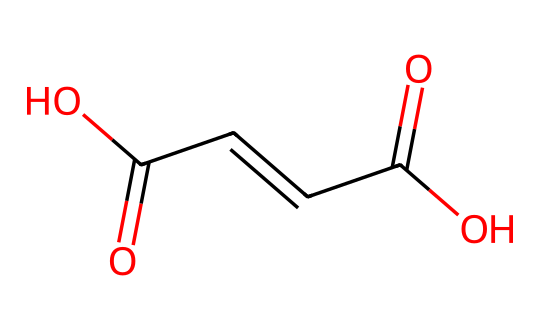What is the IUPAC name of this compound? The structure shown is a dicarboxylic acid, which features two carboxylic acid (-COOH) groups, and its systematic name follows the conventions for naming such compounds. The correct naming convention leads to the name "fumaric acid."
Answer: fumaric acid How many double bonds are present in this molecule? The visual representation of the chemical reveals one double bond between the carbon atoms in the middle of the carbon chain. Therefore, there is one double bond present.
Answer: one What functional groups are present in this compound? By analyzing the structure, we identify that there are two carboxylic acid groups (-COOH) attached to the ends of the double bond. Hence, the functional groups are two carboxylic acid groups.
Answer: carboxylic acid Which geometric isomer is represented by this SMILES string? The orientation of the carboxylic acid groups relative to the double bond indicates a specific spatial arrangement. This SMILES represents fumaric acid, which has a trans configuration.
Answer: trans What distinguishes maleic acid from fumaric acid in terms of geometric isomerism? Maleic acid is the cis isomer where the carboxylic acid groups are on the same side of the double bond, while fumaric acid is the trans isomer with them on opposite sides. Thus, the distinguishing factor is the spatial arrangement of the carboxylic groups around the double bond.
Answer: arrangement How many carbon atoms are in this molecule? Counting the number of carbon (C) atoms in the structure, we see that there are four carbon atoms in total connected in a chain formation, confirmed by looking at each part of the SMILES representation.
Answer: four Can fumaric acid and maleic acid be interconverted? Fumaric acid and maleic acid can interconvert through a chemical reaction, specifically by a cis-trans isomerization process, which allows for the transformation between the two forms under certain conditions.
Answer: yes 